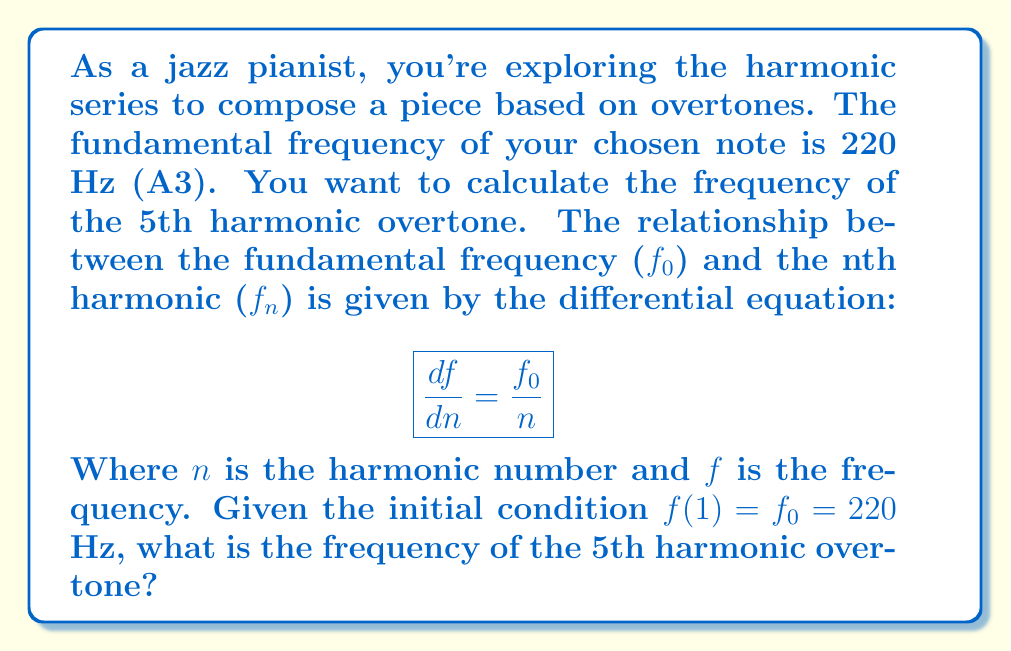Teach me how to tackle this problem. Let's solve this step-by-step:

1) We start with the differential equation:
   $$\frac{df}{dn} = \frac{f_0}{n}$$

2) To solve this, we need to integrate both sides:
   $$\int df = \int \frac{f_0}{n} dn$$

3) Integrating:
   $$f = f_0 \ln(n) + C$$
   Where $C$ is a constant of integration.

4) We can find $C$ using the initial condition $f(1) = f_0 = 220$:
   $$220 = 220 \ln(1) + C$$
   $$220 = 0 + C$$
   $$C = 220$$

5) So our general solution is:
   $$f(n) = 220 \ln(n) + 220$$

6) To find the 5th harmonic, we substitute $n = 5$:
   $$f(5) = 220 \ln(5) + 220$$

7) Calculating:
   $$f(5) = 220 \cdot 1.6094 + 220 = 354.068 + 220 = 574.068$$

Therefore, the frequency of the 5th harmonic overtone is approximately 574.07 Hz.
Answer: 574.07 Hz 